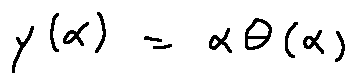<formula> <loc_0><loc_0><loc_500><loc_500>y ( \alpha ) = \alpha \theta ( \alpha )</formula> 